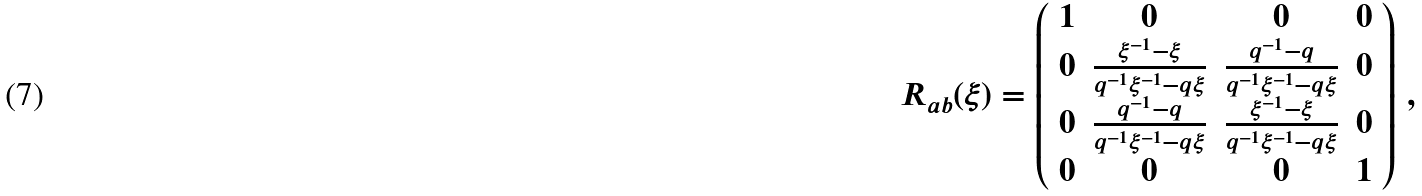Convert formula to latex. <formula><loc_0><loc_0><loc_500><loc_500>R _ { a b } ( \xi ) = \left ( \begin{array} { c c c c } { 1 } & { 0 } & { 0 } & { 0 } \\ { 0 } & { { \frac { \xi ^ { - 1 } - \xi } { q ^ { - 1 } \xi ^ { - 1 } - q \xi } } } & { { \frac { q ^ { - 1 } - q } { q ^ { - 1 } \xi ^ { - 1 } - q \xi } } } & { 0 } \\ { 0 } & { { \frac { q ^ { - 1 } - q } { q ^ { - 1 } \xi ^ { - 1 } - q \xi } } } & { { \frac { \xi ^ { - 1 } - \xi } { q ^ { - 1 } \xi ^ { - 1 } - q \xi } } } & { 0 } \\ { 0 } & { 0 } & { 0 } & { 1 } \end{array} \right ) \, ,</formula> 